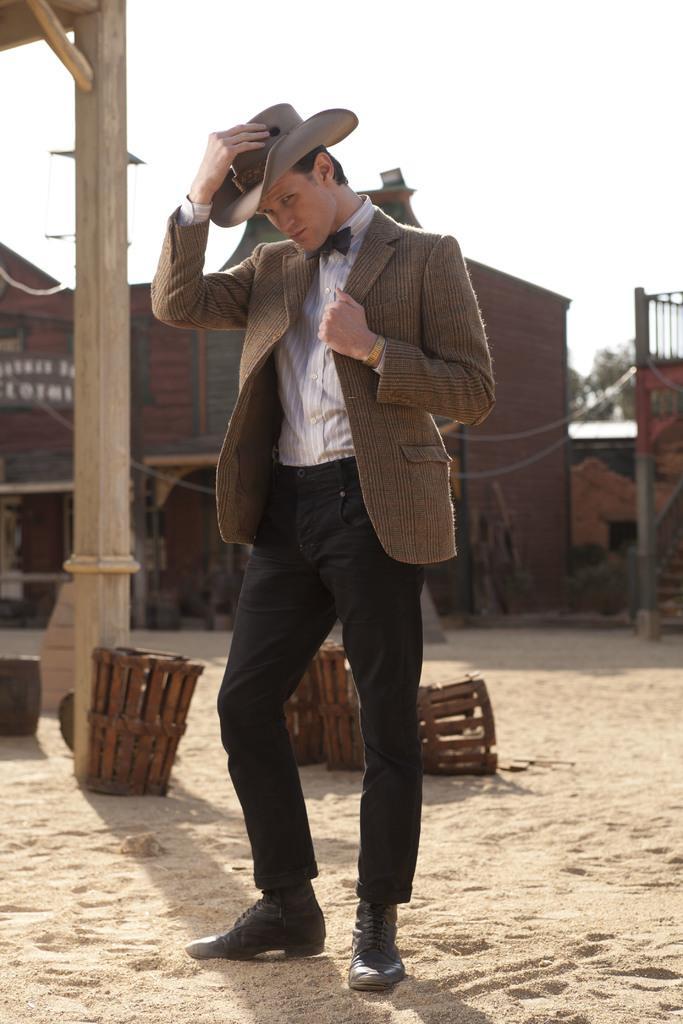Could you give a brief overview of what you see in this image? In this image we can see a house. A man is standing in the image. There are many objects in the image. There is a sky in the image. 